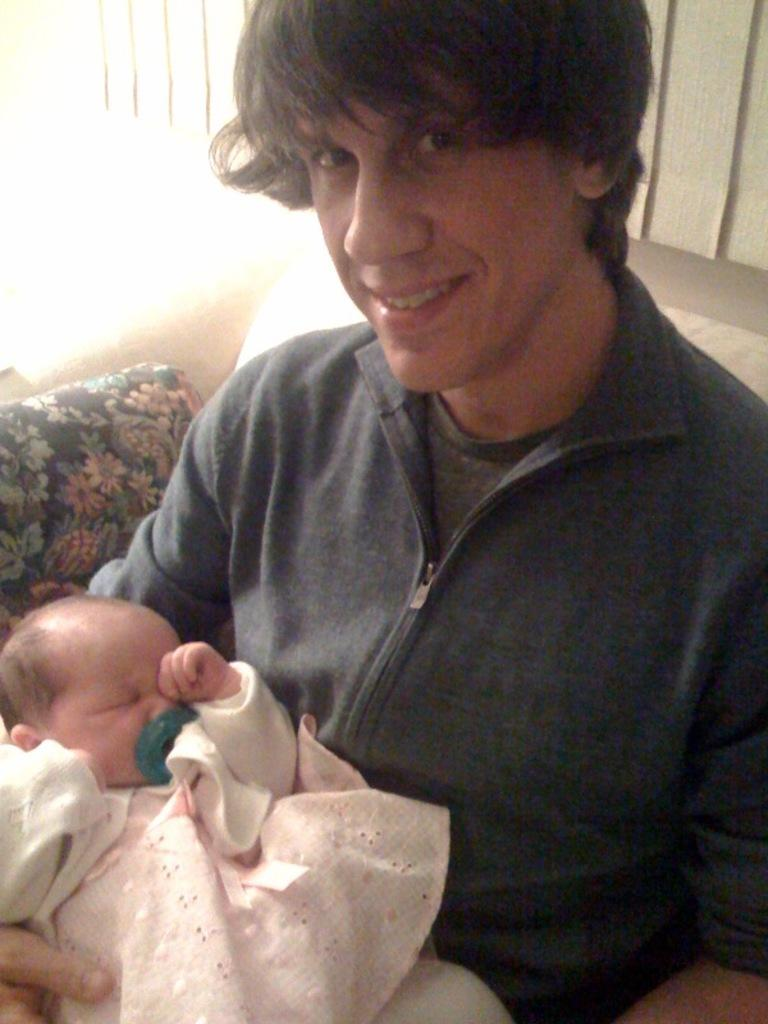Who is the main subject in the image? There is a man in the image. What is the man doing in the image? The man is sitting on a couch and carrying a baby in his hands. What is the man's facial expression in the image? The man is smiling in the image. What is the man looking at in the image? The man is looking at a picture. What type of twig is the man holding in his hand in the image? There is no twig present in the image; the man is carrying a baby in his hands. What type of rice is being served on the table in the image? There is no table or rice present in the image; the man is sitting on a couch and looking at a picture. 